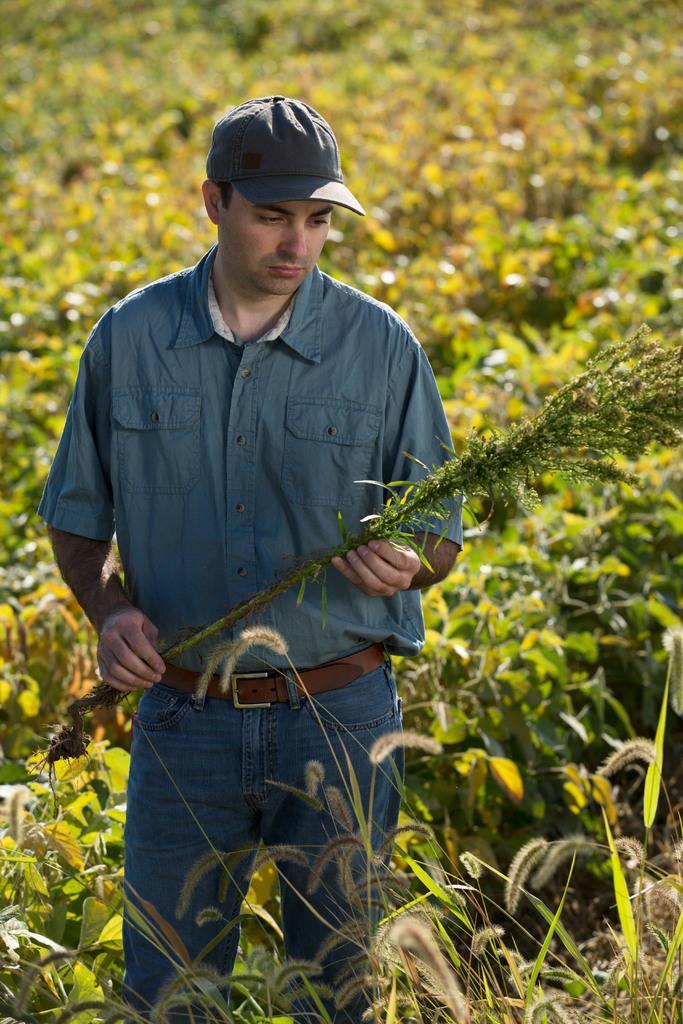In one or two sentences, can you explain what this image depicts? In this image, I see person wearing a blue colored shirt, blue color pant and a blue colored cap and he is holding a plant in his hand. In the background I can see a lots of plants. 